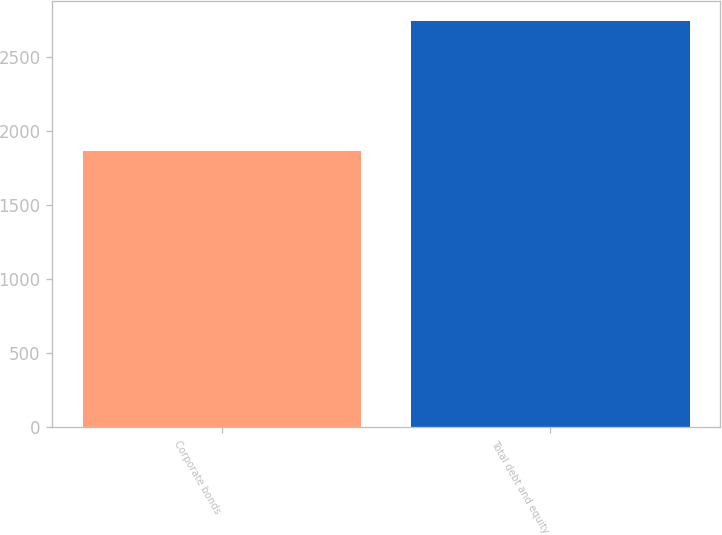Convert chart. <chart><loc_0><loc_0><loc_500><loc_500><bar_chart><fcel>Corporate bonds<fcel>Total debt and equity<nl><fcel>1865<fcel>2738<nl></chart> 